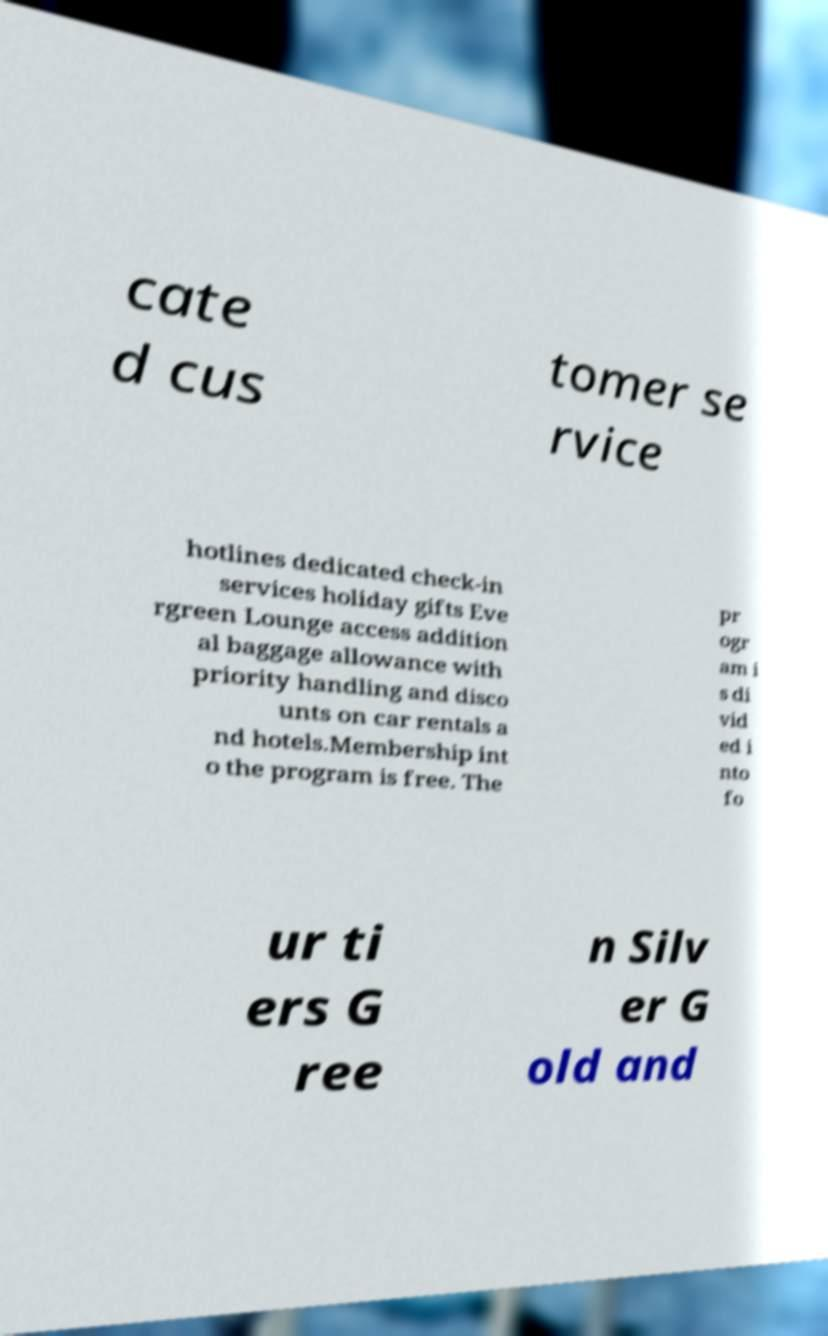Please identify and transcribe the text found in this image. cate d cus tomer se rvice hotlines dedicated check-in services holiday gifts Eve rgreen Lounge access addition al baggage allowance with priority handling and disco unts on car rentals a nd hotels.Membership int o the program is free. The pr ogr am i s di vid ed i nto fo ur ti ers G ree n Silv er G old and 